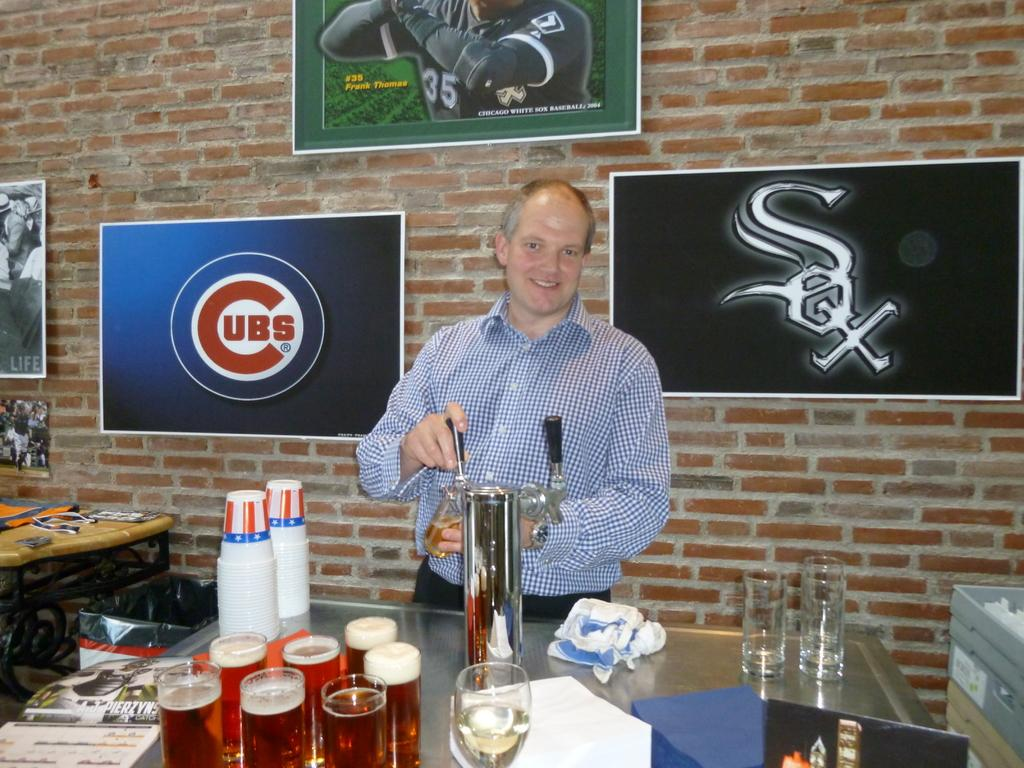Provide a one-sentence caption for the provided image. A man is pouring beer out of a tap and behind him are logos for both the Cubs and Sox. 